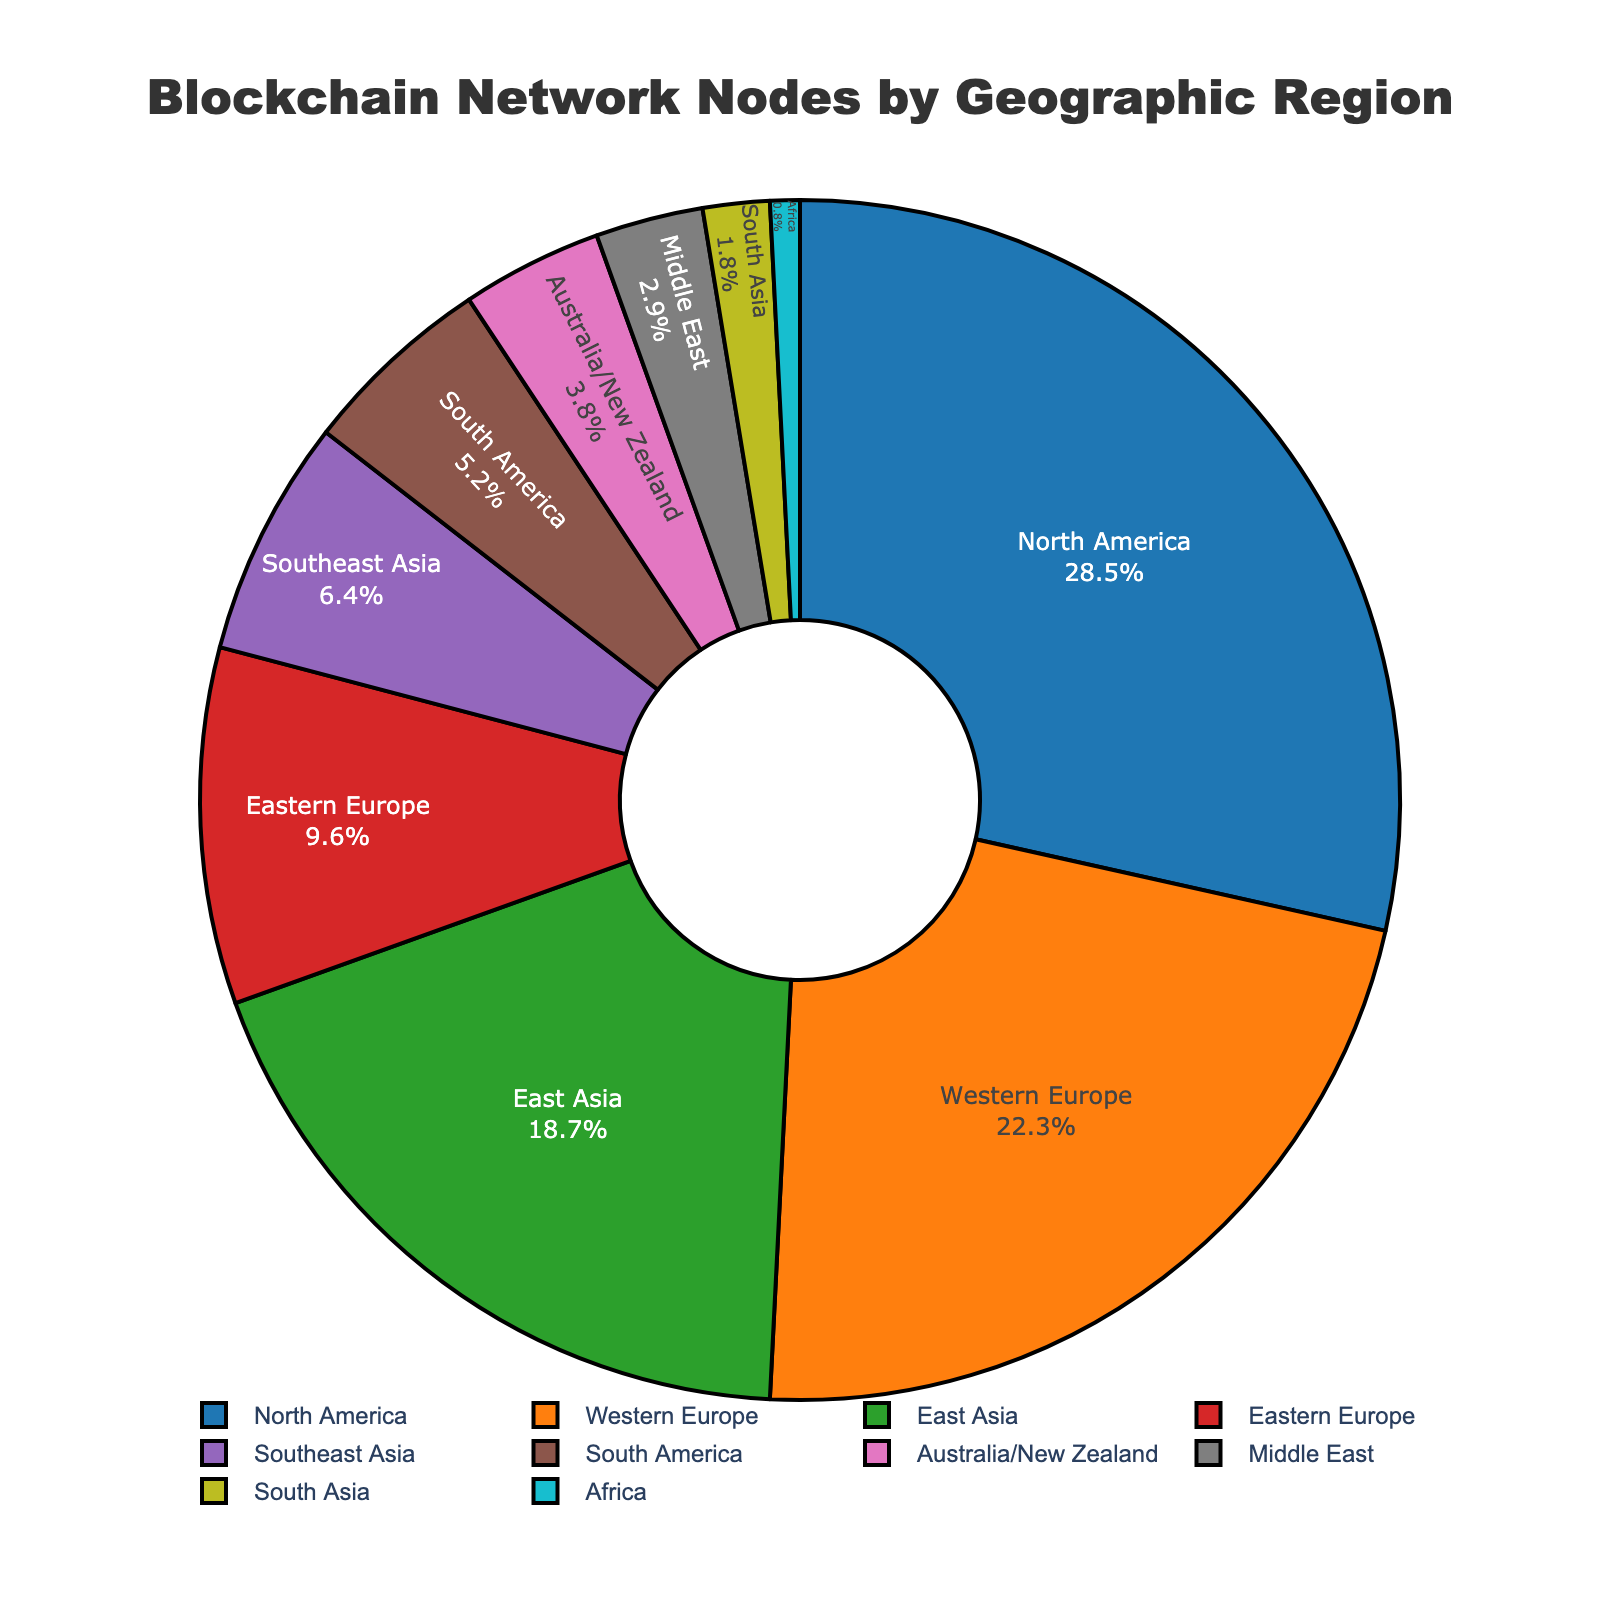What is the percentage of blockchain network nodes located in North America? Refer to the figure and locate the section labeled "North America." The percentage is shown as 28.5%.
Answer: 28.5% Which region has the smallest percentage of blockchain network nodes? Refer to the figure and locate the smallest segment. The segment labeled "Africa" has the smallest percentage, shown as 0.8%.
Answer: Africa What is the combined percentage of blockchain network nodes in North America and Western Europe? Add the percentages for North America (28.5%) and Western Europe (22.3%). 28.5 + 22.3 = 50.8%
Answer: 50.8% Does East Asia have a higher percentage of blockchain network nodes than South America? If so, by how much? Compare the percentages for East Asia (18.7%) and South America (5.2%). Subtract South America's percentage from East Asia's: 18.7 - 5.2 = 13.5%
Answer: Yes, by 13.5% Is the percentage of blockchain network nodes in Southeast Asia closer to Eastern Europe or South America? Compare the percentage for Southeast Asia (6.4%) with those of Eastern Europe (9.6%) and South America (5.2%). The difference between Southeast Asia and Eastern Europe is 9.6 - 6.4 = 3.2%, and with South America, it's 6.4 - 5.2 = 1.2%. Southeast Asia is closer to South America.
Answer: South America What is the total percentage of blockchain network nodes from regions in Asia (East Asia, Southeast Asia, South Asia, and the Middle East)? Add the percentages for East Asia (18.7%), Southeast Asia (6.4%), South Asia (1.8%), and the Middle East (2.9%). 18.7 + 6.4 + 1.8 + 2.9 = 29.8%
Answer: 29.8% Which regions combined contribute to more than 50% of the blockchain network nodes? Add the largest percentages until the sum exceeds 50%. The top three regions are North America (28.5%), Western Europe (22.3%), and East Asia (18.7%). Adding these, we get 28.5 + 22.3 + 18.7 = 69.5%. Thus, North America, Western Europe, and East Asia together contribute more than 50%.
Answer: North America, Western Europe, East Asia By what percentage does Western Europe exceed Southeast Asia in blockchain network nodes? Subtract the percentage of Southeast Asia (6.4%) from Western Europe (22.3%). 22.3 - 6.4 = 15.9%
Answer: 15.9% How many regions have a percentage of blockchain network nodes less than 5%? Refer to the figure and count the segments with percentages less than 5%. The regions are South America (5.2%), Australia/New Zealand (3.8%), Middle East (2.9%), South Asia (1.8%), and Africa (0.8%). Hence, there are four regions.
Answer: 5 Which region has a slightly smaller percentage of blockchain network nodes compared to South America? Find the region with a percentage just below South America's 5.2%. The "Australia/New Zealand" region has 3.8%, which is slightly smaller than South America's.
Answer: Australia/New Zealand 